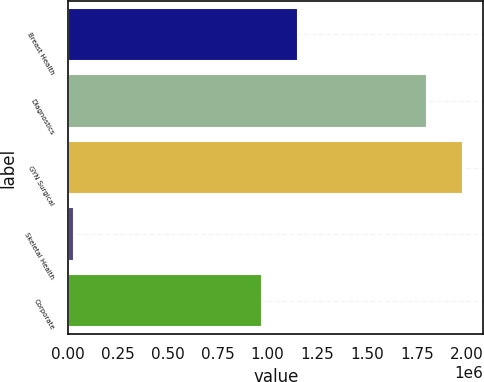Convert chart to OTSL. <chart><loc_0><loc_0><loc_500><loc_500><bar_chart><fcel>Breast Health<fcel>Diagnostics<fcel>GYN Surgical<fcel>Skeletal Health<fcel>Corporate<nl><fcel>1.15103e+06<fcel>1.80215e+06<fcel>1.9826e+06<fcel>30293<fcel>970579<nl></chart> 